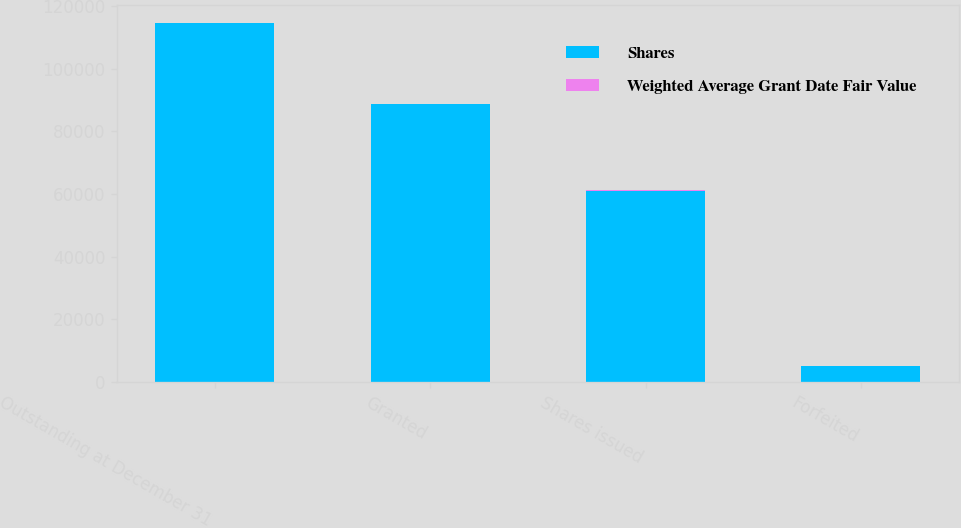<chart> <loc_0><loc_0><loc_500><loc_500><stacked_bar_chart><ecel><fcel>Outstanding at December 31<fcel>Granted<fcel>Shares issued<fcel>Forfeited<nl><fcel>Shares<fcel>114599<fcel>88715<fcel>61083<fcel>5000<nl><fcel>Weighted Average Grant Date Fair Value<fcel>47.03<fcel>31.91<fcel>27.13<fcel>28.91<nl></chart> 